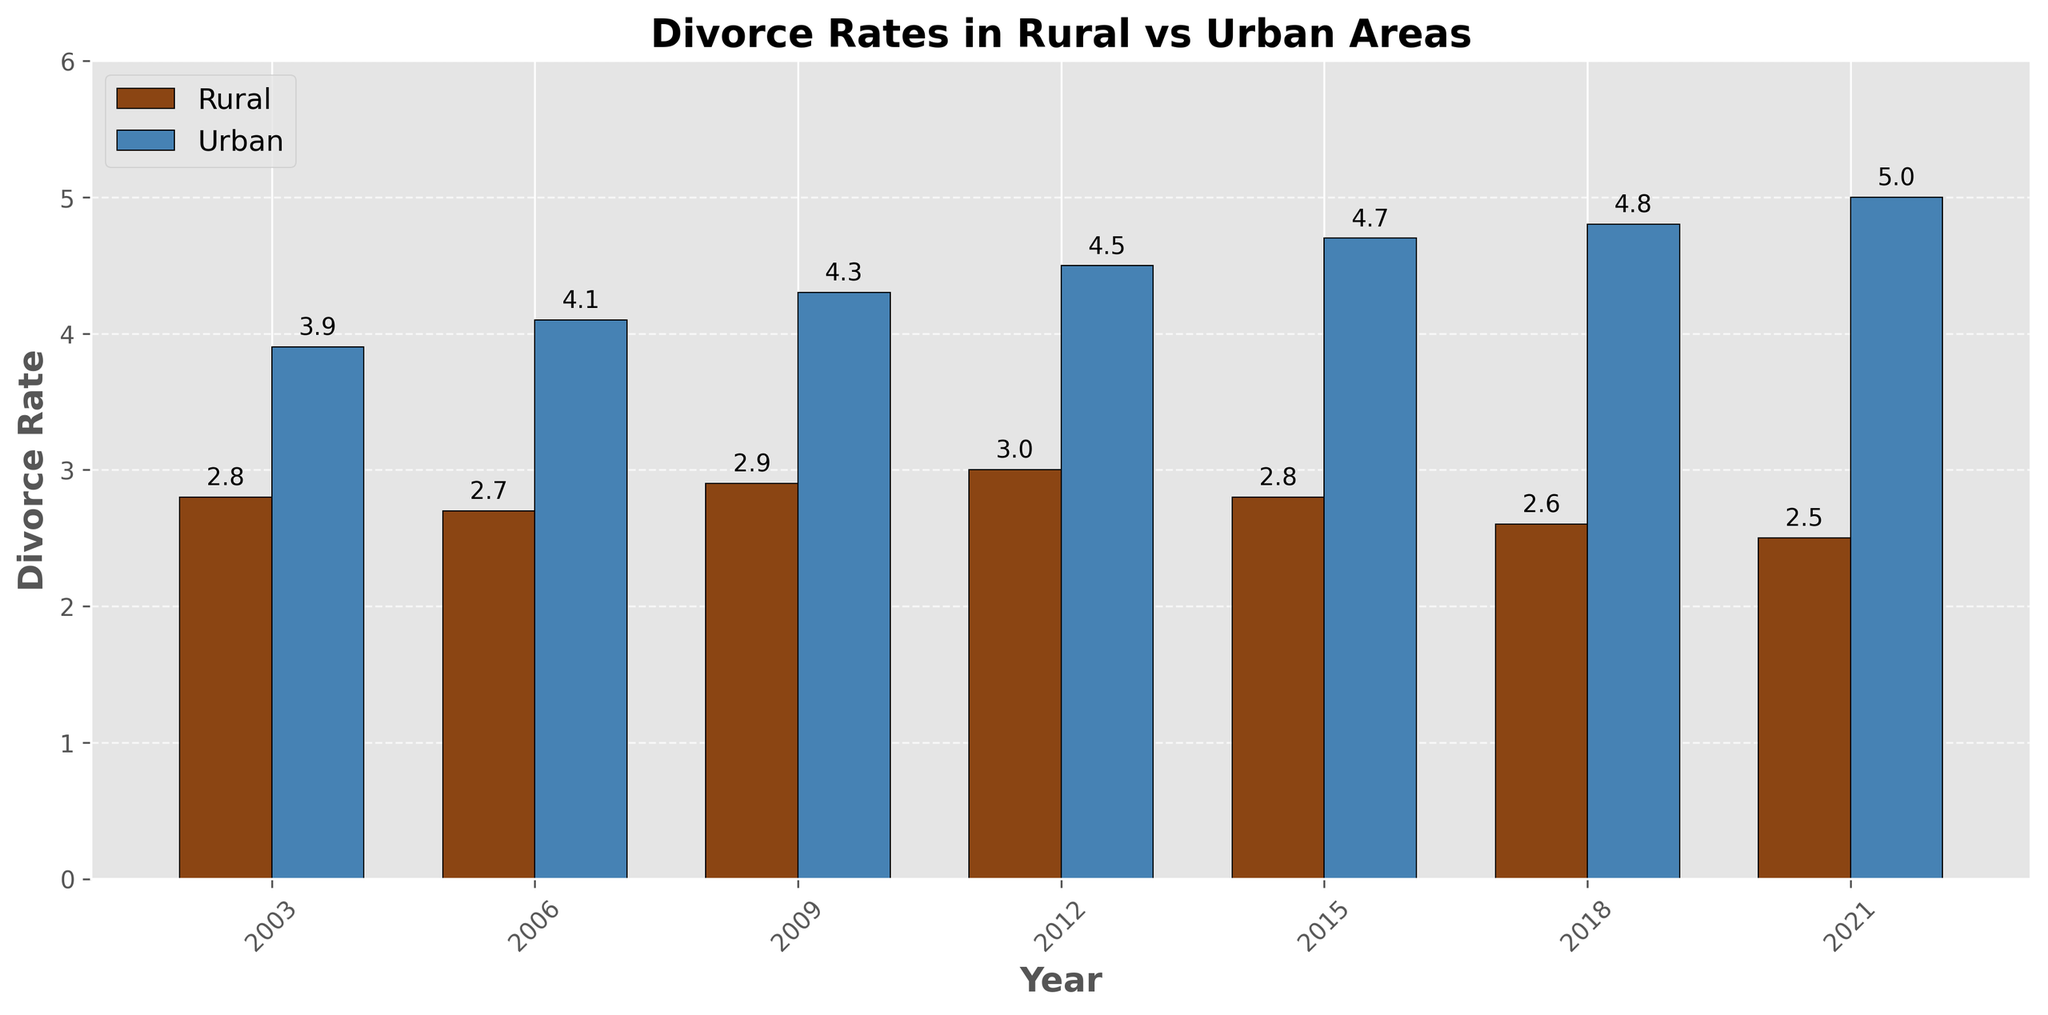What is the overall trend in divorce rates over the 20 years for rural areas? First, observe the bars representing the rural divorce rates from 2003 to 2021. Notice that the height of the bars decreases from 2.8 in 2003 to 2.5 in 2021. This indicates a downward trend in the rural divorce rates over the 20-year period.
Answer: Downward Which year shows the highest divorce rate for urban areas? Look at the bars representing the urban divorce rates and find the tallest bar. The tallest bar corresponds to the year 2021 with a value of 5.0.
Answer: 2021 How much higher was the urban divorce rate compared to the rural divorce rate in 2021? Find the difference between the urban divorce rate and the rural divorce rate in 2021. The urban rate is 5.0, and the rural rate is 2.5. Subtract the rural rate from the urban rate (5.0 - 2.5) to get the difference.
Answer: 2.5 What is the average rural divorce rate over the 20 years? To find the average, sum the rural divorce rates from 2003 to 2021 and divide by the number of years. (2.8 + 2.7 + 2.9 + 3.0 + 2.8 + 2.6 + 2.5) / 7 equals 19.3 / 7.
Answer: 2.76 In which year(s) is the rural divorce rate higher than 2.9? Identify the years where the height of the rural divorce rate bars is greater than 2.9. Only the year 2012 with a rate of 3.0 qualifies.
Answer: 2012 Compare the divorce rates between rural and urban areas in 2009. Look at the bars for the year 2009. The rural divorce rate is 2.9, while the urban divorce rate is 4.3. Therefore, the urban rate is higher.
Answer: Urban is higher How did the urban divorce rate change from 2006 to 2021? Observe the urban divorce rate bars for 2006 and 2021. In 2006, the rate is 4.1, and in 2021, it is 5.0. Subtract 4.1 from 5.0 to find the increase, which is 0.9.
Answer: Increased by 0.9 Which area generally has a higher divorce rate, rural or urban? Compare the heights of the bars representing rural and urban divorce rates for each year. Urban bars are consistently taller than rural bars across all years, indicating that urban areas have generally higher divorce rates.
Answer: Urban What was the increase in rural divorce rates from 2006 to 2012? Note the rural divorce rates for 2006 and 2012, which are 2.7 and 3.0, respectively. Subtract 2.7 from 3.0 to find the increase.
Answer: 0.3 Is there any year where the rural divorce rate is equal to the urban divorce rate? Examine the bars for all years to see if any rural and urban bars are of equal height. There isn't a single year where the rural and urban divorce rates are the same in the given data.
Answer: No 